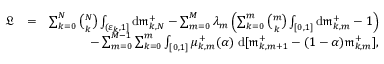Convert formula to latex. <formula><loc_0><loc_0><loc_500><loc_500>\begin{array} { r l r } { \mathfrak { L } } & { = } & { \sum _ { k = 0 } ^ { N } { \binom { N } { k } } \int _ { ( \varepsilon _ { k } , 1 ] } d \mathfrak { m } _ { k , N } ^ { + } - \sum _ { m = 0 } ^ { M } \lambda _ { m } \left ( \sum _ { k = 0 } ^ { m } { \binom { m } { k } } \int _ { [ 0 , 1 ] } d \mathfrak { m } _ { k , m } ^ { + } - 1 \right ) } \\ & { - \sum _ { m = 0 } ^ { M - 1 } \sum _ { k = 0 } ^ { m } \int _ { [ 0 , 1 ] } \mu _ { k , m } ^ { + } ( \alpha ) \, d [ \mathfrak { m } _ { k , m + 1 } ^ { + } - ( 1 - \alpha ) \mathfrak { m } _ { k , m } ^ { + } ] , } \end{array}</formula> 